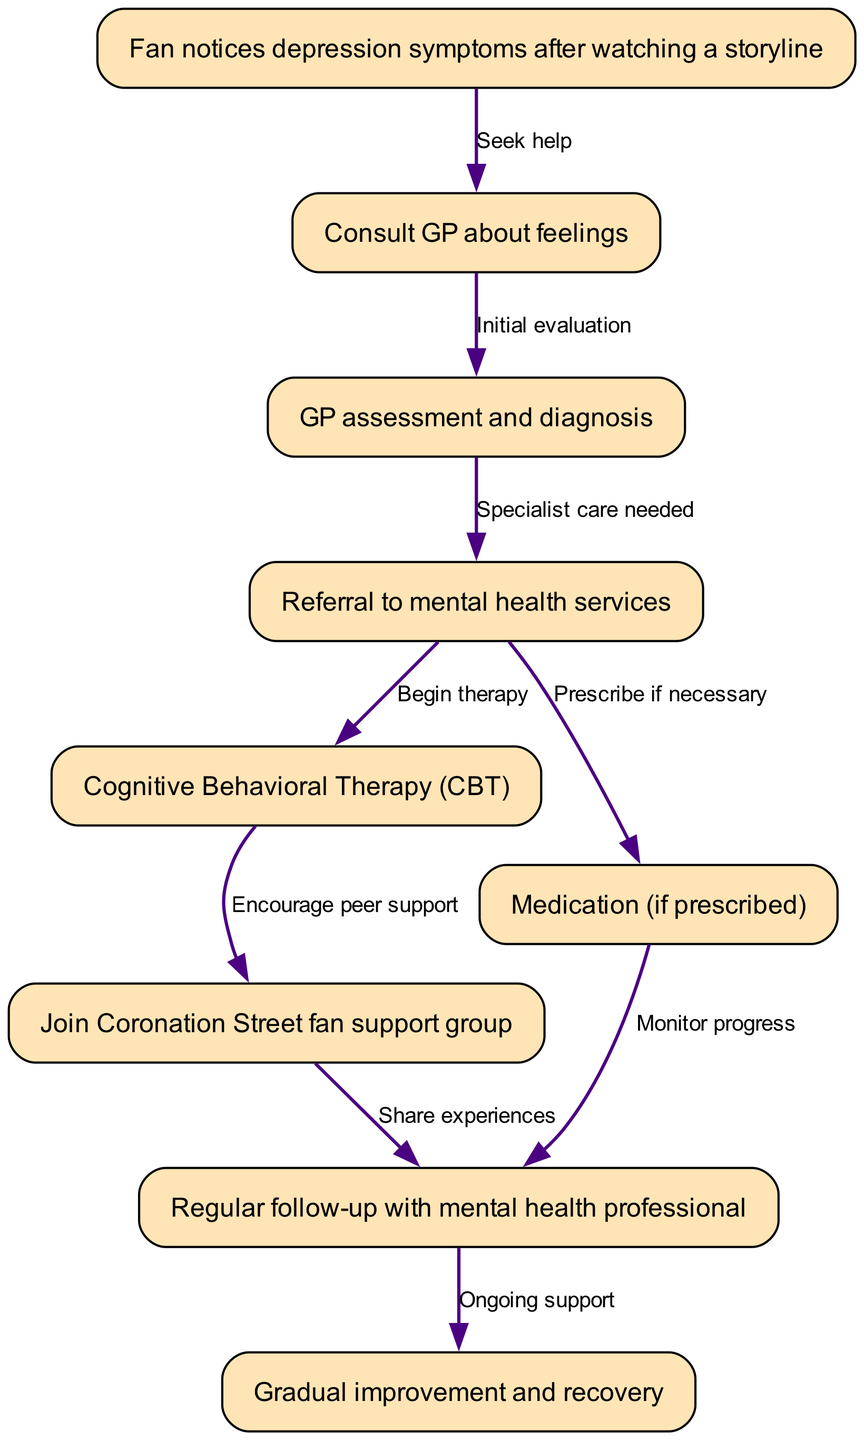What is the first node in the pathway? The first node in the pathway is labeled "Fan notices depression symptoms after watching a storyline." It is the starting point representing the fan's initial awareness of their feelings.
Answer: Fan notices depression symptoms after watching a storyline How many nodes are present in the diagram? To find the number of nodes, we can count each node listed in the provided data. There are a total of 9 nodes in the diagram.
Answer: 9 What is the last step before recovery? The last step before recovery is the node labeled "Regular follow-up with mental health professional," which is crucial for ongoing support during the recovery process.
Answer: Regular follow-up with mental health professional Which node follows the GP assessment? The node that follows the "GP assessment and diagnosis" is "Referral to mental health services" indicating that a specialist is needed for further care.
Answer: Referral to mental health services How many edges connect to the medication node? The "Medication (if prescribed)" node has 1 edge connecting it to "Regular follow-up with mental health professional," indicating that progress will be monitored after prescription.
Answer: 1 What two nodes can be initiated from "Referral to mental health services"? From "Referral to mental health services," two nodes can be initiated: "Cognitive Behavioral Therapy (CBT)" and "Medication (if prescribed)," suggesting parallel treatment options.
Answer: Cognitive Behavioral Therapy (CBT) and Medication (if prescribed) What indicates ongoing support in the pathway? The node labeled "Ongoing support" indicates that continuing care is essential for the person during their recovery process after all previous steps are completed.
Answer: Ongoing support What is the relationship between CBT and the fan support group? The relationship is that "Cognitive Behavioral Therapy (CBT)" leads to "Join Coronation Street fan support group," suggesting that therapy encourages peer support among fans.
Answer: Encourage peer support 